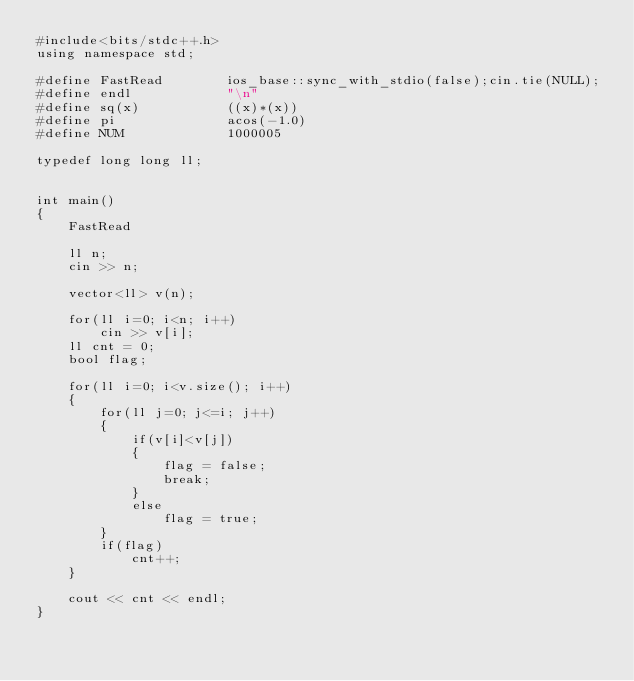<code> <loc_0><loc_0><loc_500><loc_500><_C++_>#include<bits/stdc++.h>
using namespace std;

#define FastRead        ios_base::sync_with_stdio(false);cin.tie(NULL);
#define endl            "\n"
#define sq(x)           ((x)*(x))
#define pi              acos(-1.0)
#define NUM             1000005

typedef long long ll;


int main()
{
    FastRead

    ll n;
    cin >> n;

    vector<ll> v(n);

    for(ll i=0; i<n; i++)
        cin >> v[i];
    ll cnt = 0;
    bool flag;

    for(ll i=0; i<v.size(); i++)
    {
        for(ll j=0; j<=i; j++)
        {
            if(v[i]<v[j])
            {
                flag = false;
                break;
            }
            else
                flag = true;
        }
        if(flag)
            cnt++;
    }
    
    cout << cnt << endl;
}
</code> 